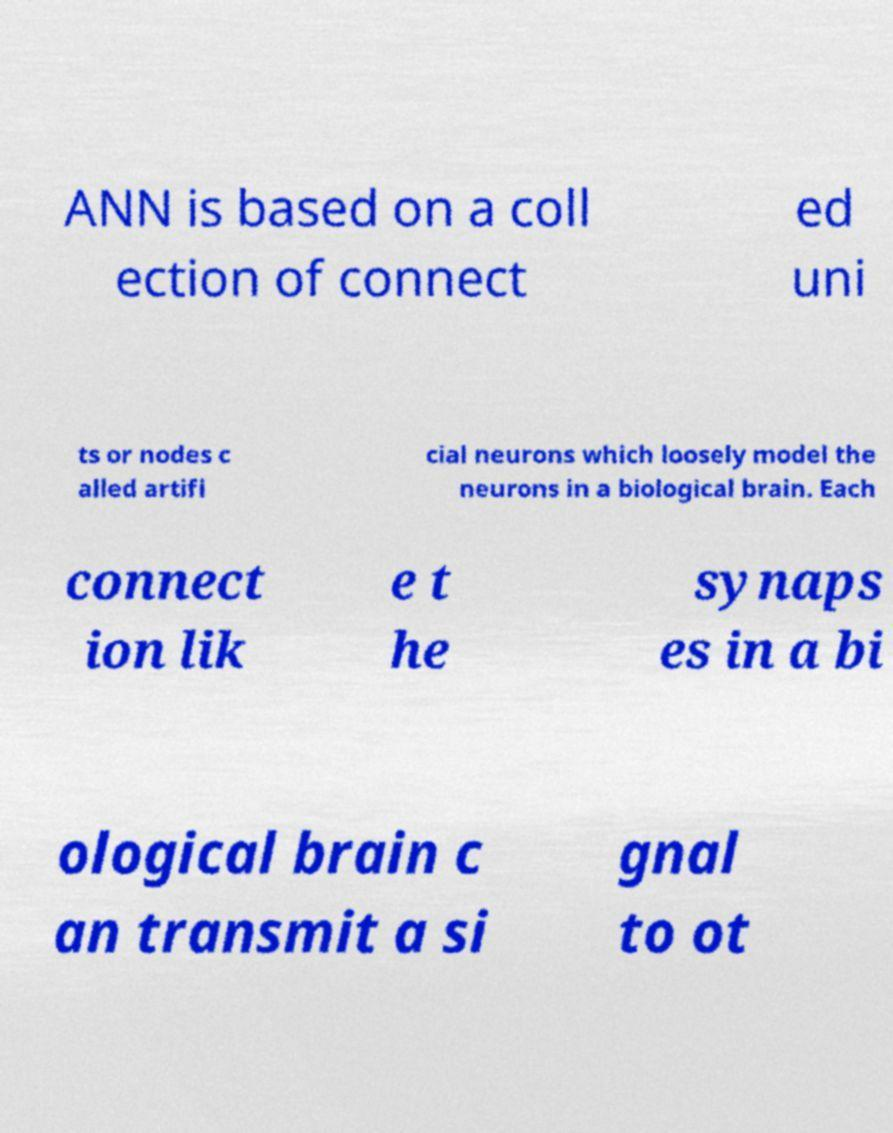Can you read and provide the text displayed in the image?This photo seems to have some interesting text. Can you extract and type it out for me? ANN is based on a coll ection of connect ed uni ts or nodes c alled artifi cial neurons which loosely model the neurons in a biological brain. Each connect ion lik e t he synaps es in a bi ological brain c an transmit a si gnal to ot 